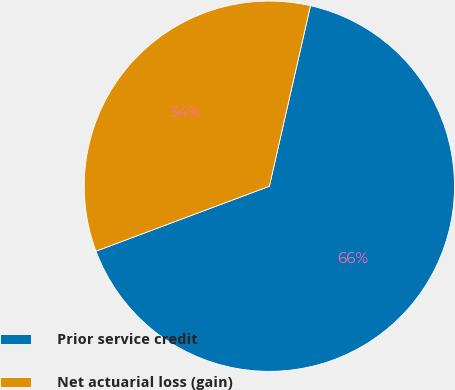Convert chart. <chart><loc_0><loc_0><loc_500><loc_500><pie_chart><fcel>Prior service credit<fcel>Net actuarial loss (gain)<nl><fcel>65.73%<fcel>34.27%<nl></chart> 